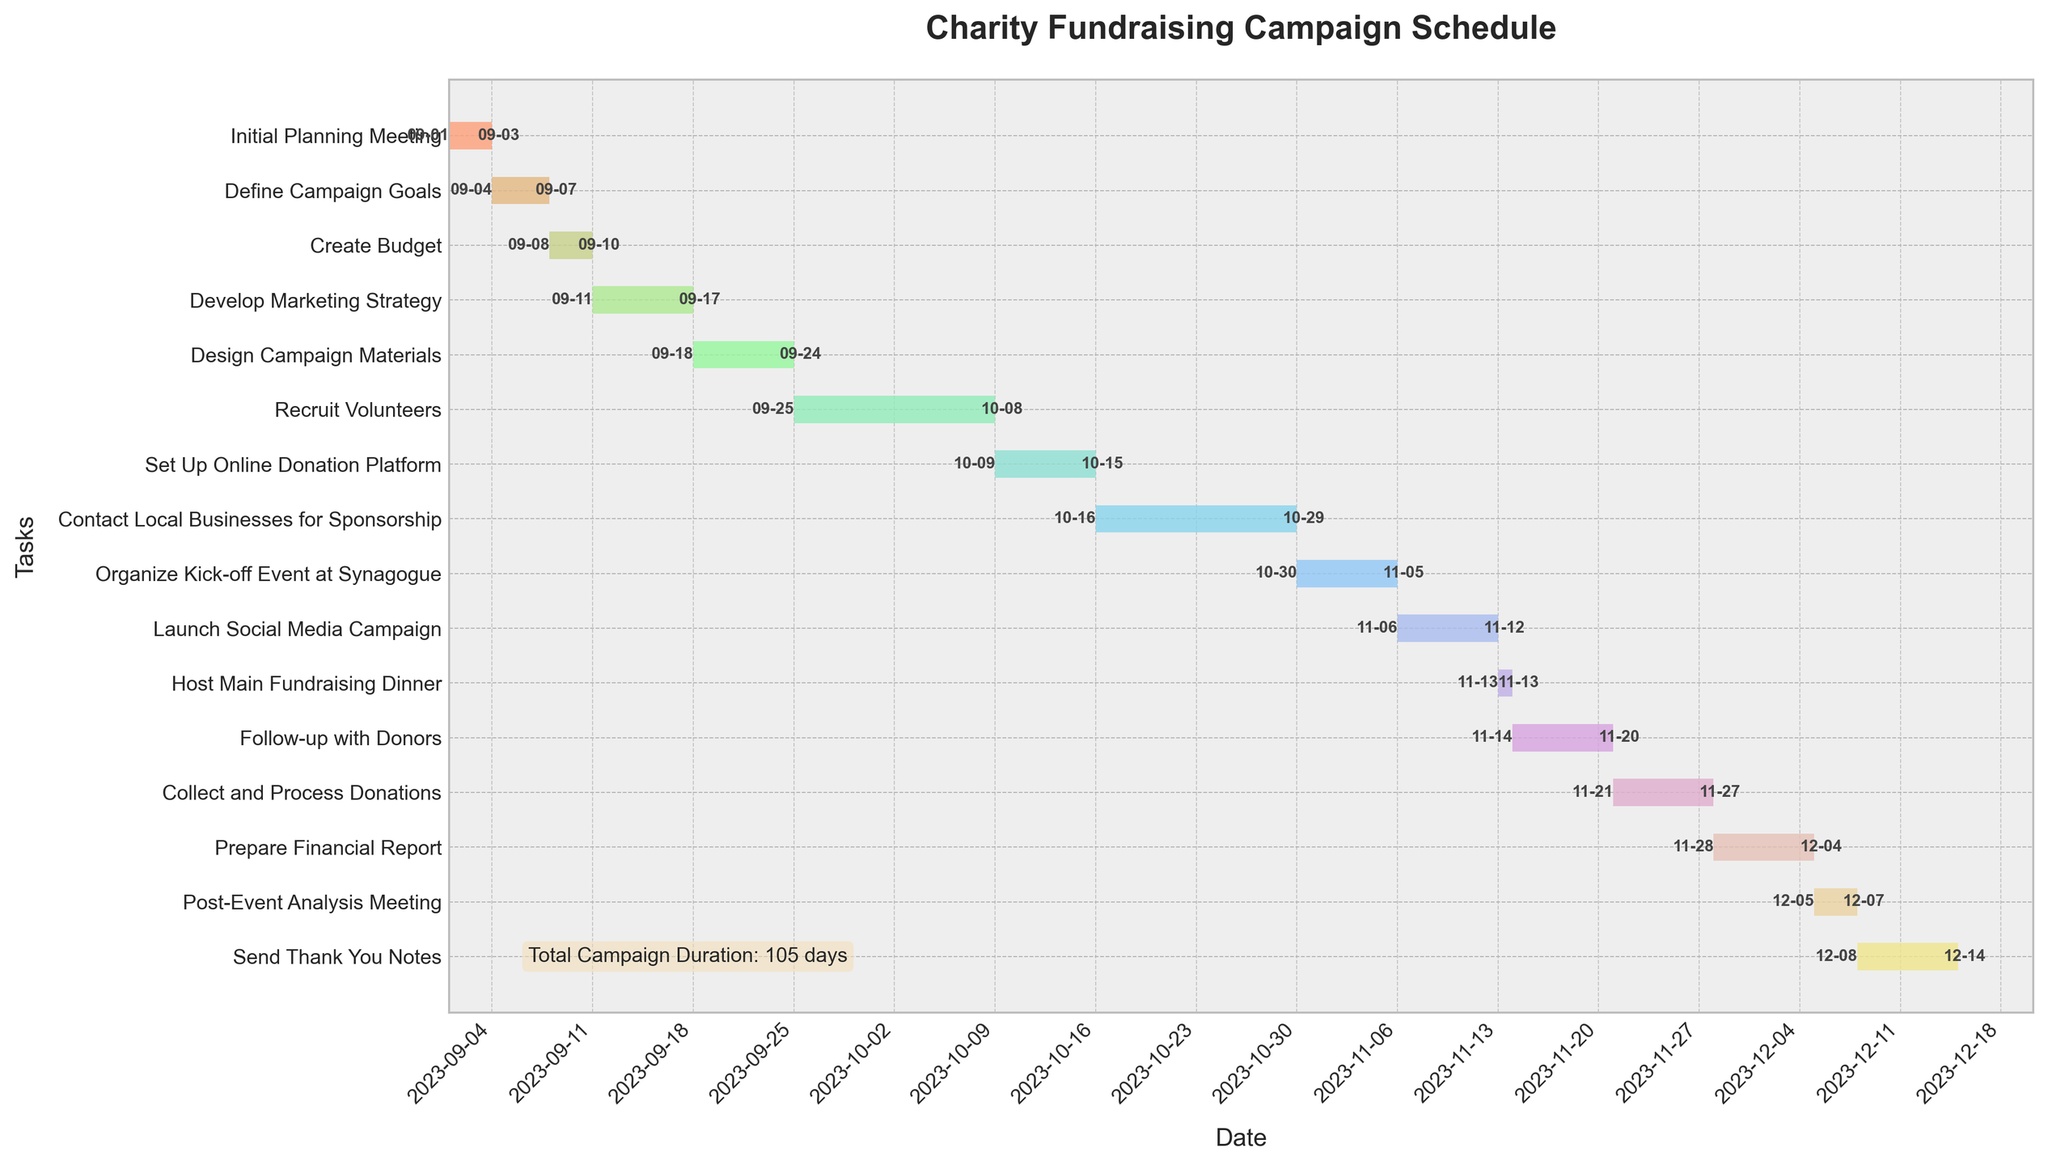What is the title of the Gantt Chart? The title of the Gantt Chart is displayed at the top center of the plot. It summarizes the contents of the chart.
Answer: Charity Fundraising Campaign Schedule What are the start and end dates of the "Recruit Volunteers" task? The "Recruit Volunteers" task can be identified in the y-axis, and the corresponding bars' start and end points mark its duration.
Answer: 2023-09-25 to 2023-10-08 Which task has the shortest duration, and how long is it? By comparing the lengths of all the bars, we can spot the shortest one. It is a single-day task.
Answer: Host Main Fundraising Dinner, 1 day How many days does it take to design campaign materials? The duration of the "Design Campaign Materials" task can be calculated by subtracting its start date from its end date and adding one day.
Answer: 7 days What tasks are scheduled to be done before October 1st, 2023? Tasks scheduled before October 1st are those with end dates before this date. By checking each bar's end date, we can list them.
Answer: Initial Planning Meeting, Define Campaign Goals, Create Budget, Develop Marketing Strategy, Design Campaign Materials How long is the entire campaign duration? The entire campaign duration is calculated by subtracting the earliest start date from the latest end date and adding one day, as displayed in the text box within the plot.
Answer: 105 days Which task overlaps with the "Set Up Online Donation Platform" task? By examining the bars that align with the start and end dates of the "Set Up Online Donation Platform" task, we find overlapping tasks.
Answer: Recruit Volunteers What is the start date of the last task of the campaign, and what is it called? Identifying the last task is done by finding the task with the latest start date.
Answer: Send Thank You Notes, 2023-12-08 Compare the durations of "Develop Marketing Strategy" and "Contact Local Businesses for Sponsorship," which one is longer, and by how many days? By calculating the durations of both tasks and comparing them, we determine which one is longer and the difference in days.
Answer: Contact Local Businesses for Sponsorship, 7 days longer How many tasks are scheduled for the month of November? Counting the tasks that have a start or end date within November by examining the corresponding bars on the x-axis.
Answer: 6 tasks 